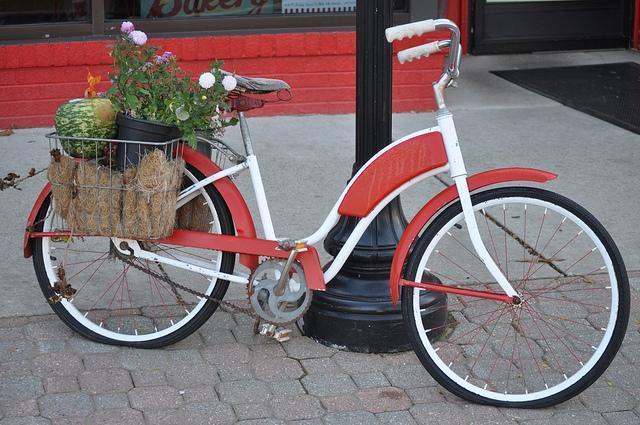How many bikes are here?
Give a very brief answer. 1. How many potted plants are there?
Give a very brief answer. 1. How many tattoos does the woman have on her arm?
Give a very brief answer. 0. 